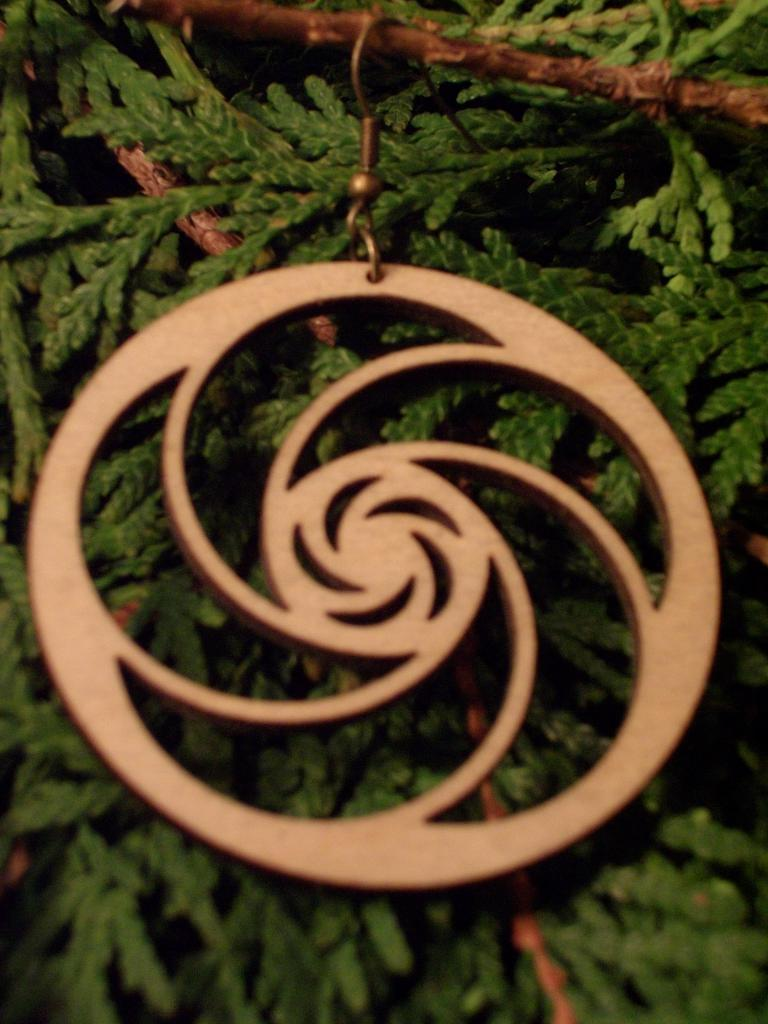What type of natural elements can be seen in the image? There are leaves in the image. What is the main subject in the middle of the image? There is a decorative object in the middle of the image. Where is the robin perched in the image? There is no robin present in the image. What type of cork material is used for the decorative object in the image? The provided facts do not mention any specific material for the decorative object, so we cannot determine if it is made of cork or any other material. 